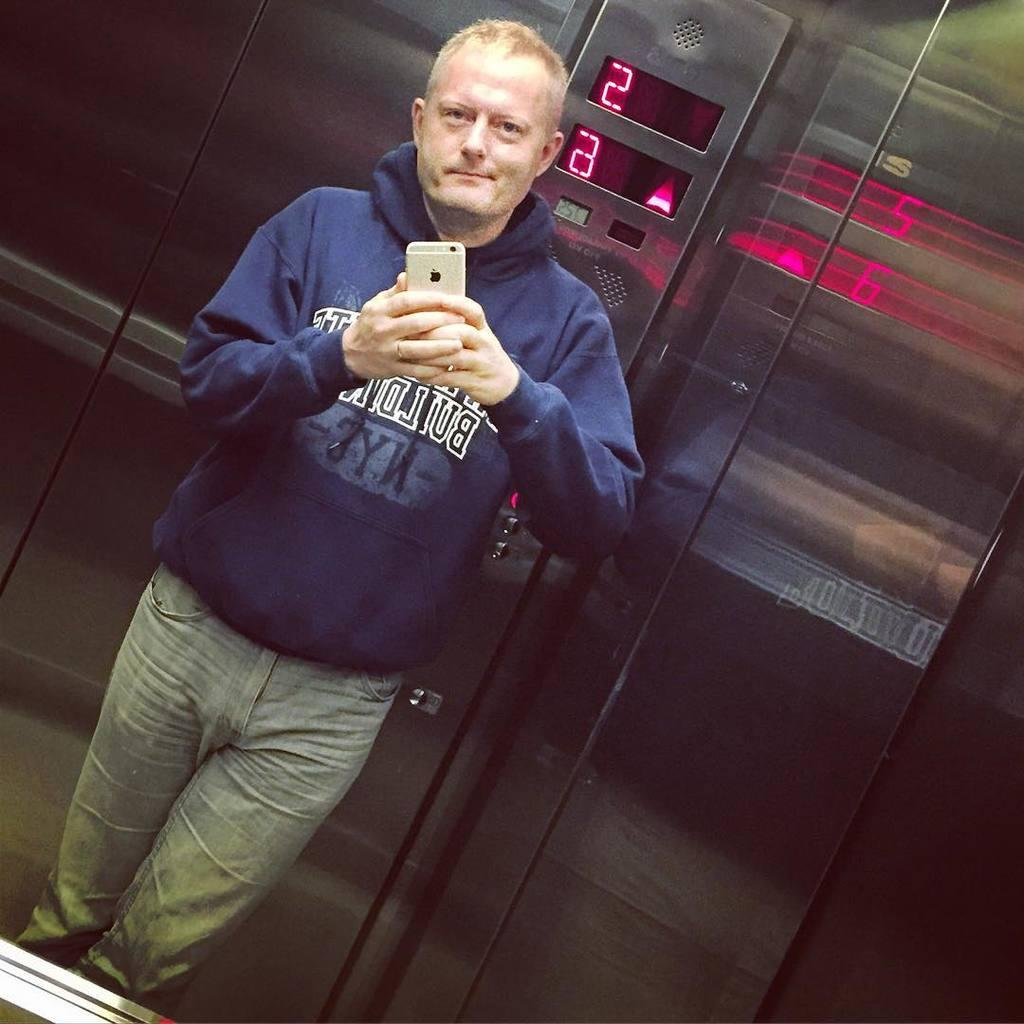Who is present in the image? There is a man in the image. What is the man wearing? The man is wearing a navy blue hoodie. What is the man holding in the image? The man is holding a cellphone. Where is the man located in the image? The man is inside an elevator. What type of butter is the man spreading on the floor in the image? There is no butter or any indication of spreading it on the floor in the image. 